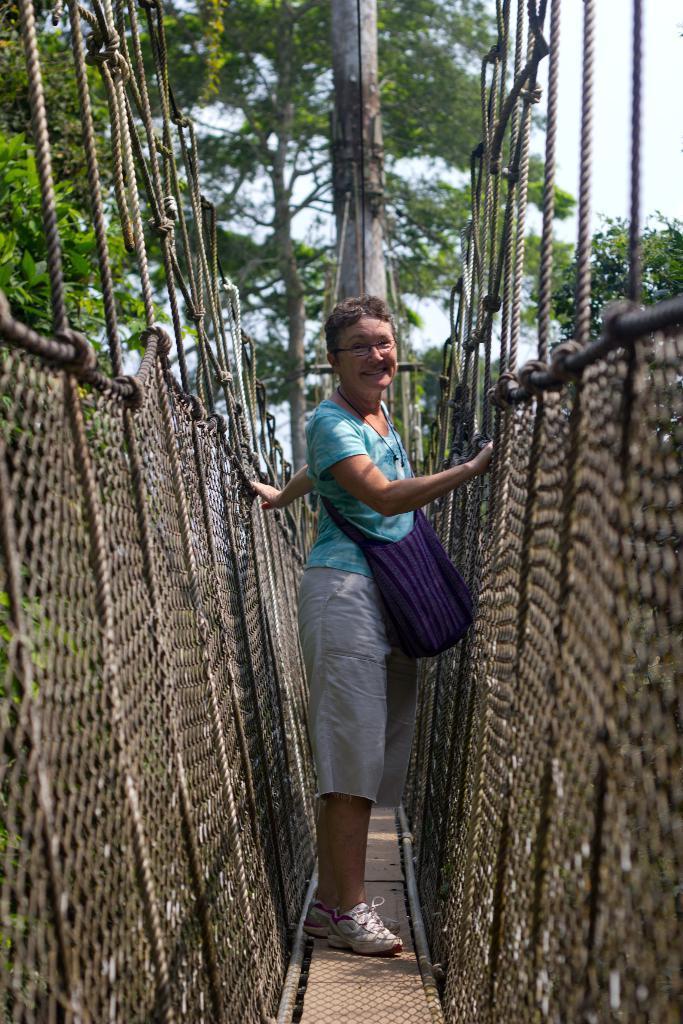Please provide a concise description of this image. In this image there is a woman standing with a smile on her face on the rope bridge, behind the woman there is a pole and trees. 